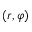Convert formula to latex. <formula><loc_0><loc_0><loc_500><loc_500>\left ( r , \varphi \right )</formula> 